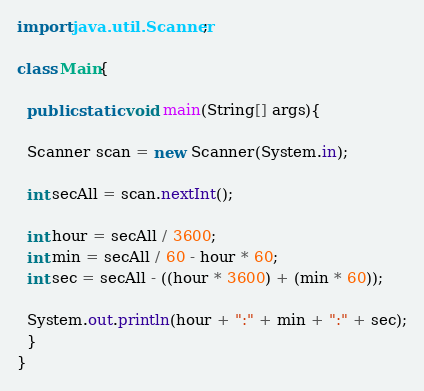<code> <loc_0><loc_0><loc_500><loc_500><_Java_>import java.util.Scanner;

class Main{

  public static void main(String[] args){
  
  Scanner scan = new Scanner(System.in);
  
  int secAll = scan.nextInt();
  
  int hour = secAll / 3600;
  int min = secAll / 60 - hour * 60;
  int sec = secAll - ((hour * 3600) + (min * 60));
  
  System.out.println(hour + ":" + min + ":" + sec);
  }
}</code> 